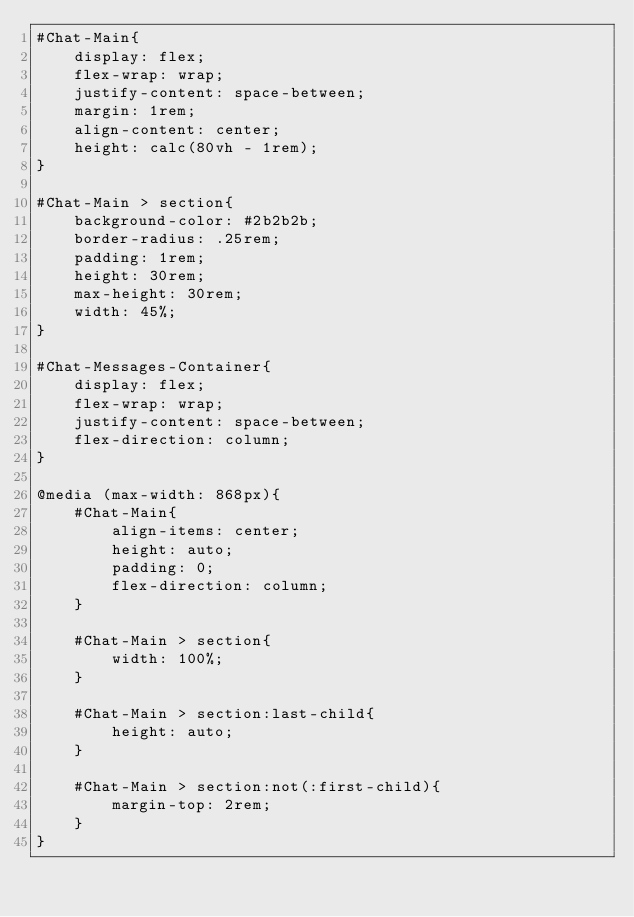Convert code to text. <code><loc_0><loc_0><loc_500><loc_500><_CSS_>#Chat-Main{
    display: flex;
    flex-wrap: wrap;
    justify-content: space-between;
    margin: 1rem;
    align-content: center;
    height: calc(80vh - 1rem);
}

#Chat-Main > section{
    background-color: #2b2b2b;
    border-radius: .25rem;
    padding: 1rem;
    height: 30rem;
    max-height: 30rem;
    width: 45%;
}

#Chat-Messages-Container{
    display: flex;
    flex-wrap: wrap;
    justify-content: space-between;
    flex-direction: column;
}

@media (max-width: 868px){
    #Chat-Main{
        align-items: center;
        height: auto;
        padding: 0;
        flex-direction: column;
    }

    #Chat-Main > section{
        width: 100%;
    }

    #Chat-Main > section:last-child{
        height: auto;
    }

    #Chat-Main > section:not(:first-child){
        margin-top: 2rem;
    }
}</code> 